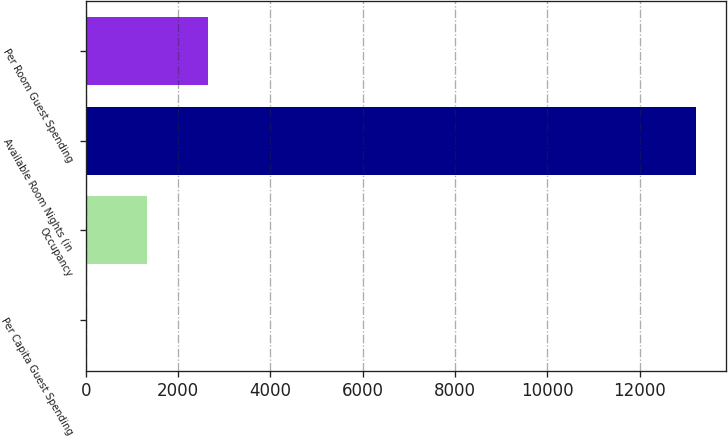Convert chart. <chart><loc_0><loc_0><loc_500><loc_500><bar_chart><fcel>Per Capita Guest Spending<fcel>Occupancy<fcel>Available Room Nights (in<fcel>Per Room Guest Spending<nl><fcel>8<fcel>1328.4<fcel>13212<fcel>2648.8<nl></chart> 